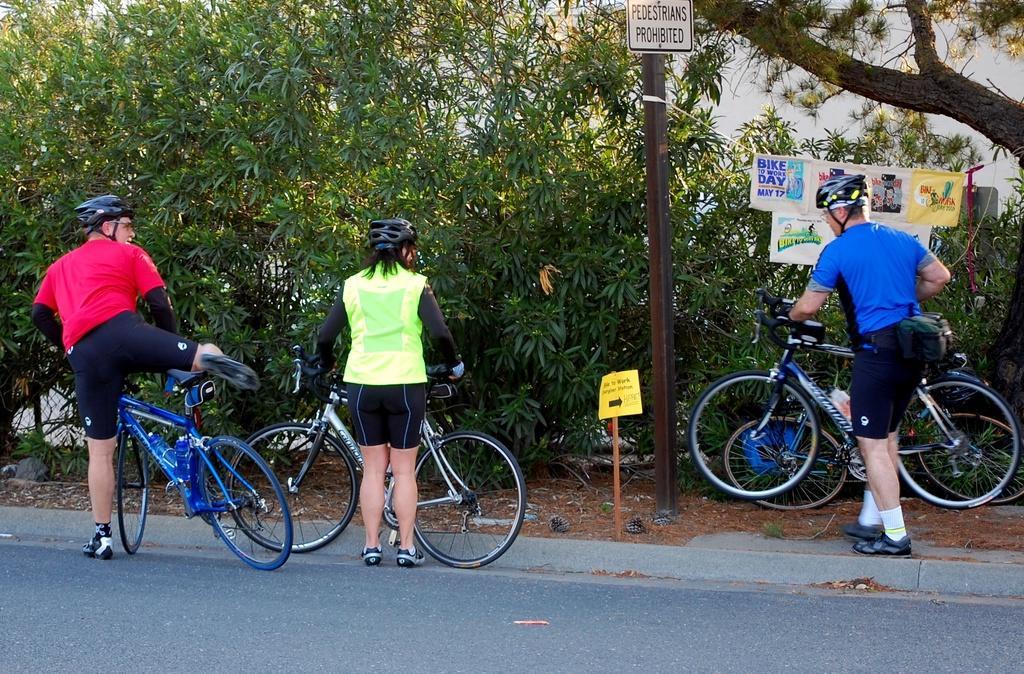In one or two sentences, can you explain what this image depicts? As we can see in the image there are trees, pole, banner, three people standing on road and holding bicycles. 